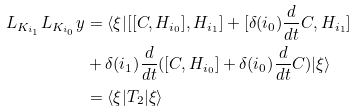<formula> <loc_0><loc_0><loc_500><loc_500>L _ { K _ { i _ { 1 } } } L _ { K _ { i _ { 0 } } } y & = \langle \xi | [ [ C , H _ { i _ { 0 } } ] , H _ { i _ { 1 } } ] + [ \delta ( i _ { 0 } ) \frac { d } { d t } C , H _ { i _ { 1 } } ] \\ & + \delta ( i _ { 1 } ) \frac { d } { d t } ( [ C , H _ { i _ { 0 } } ] + \delta ( i _ { 0 } ) \frac { d } { d t } C ) | \xi \rangle \\ & = \langle \xi | T _ { 2 } | \xi \rangle</formula> 